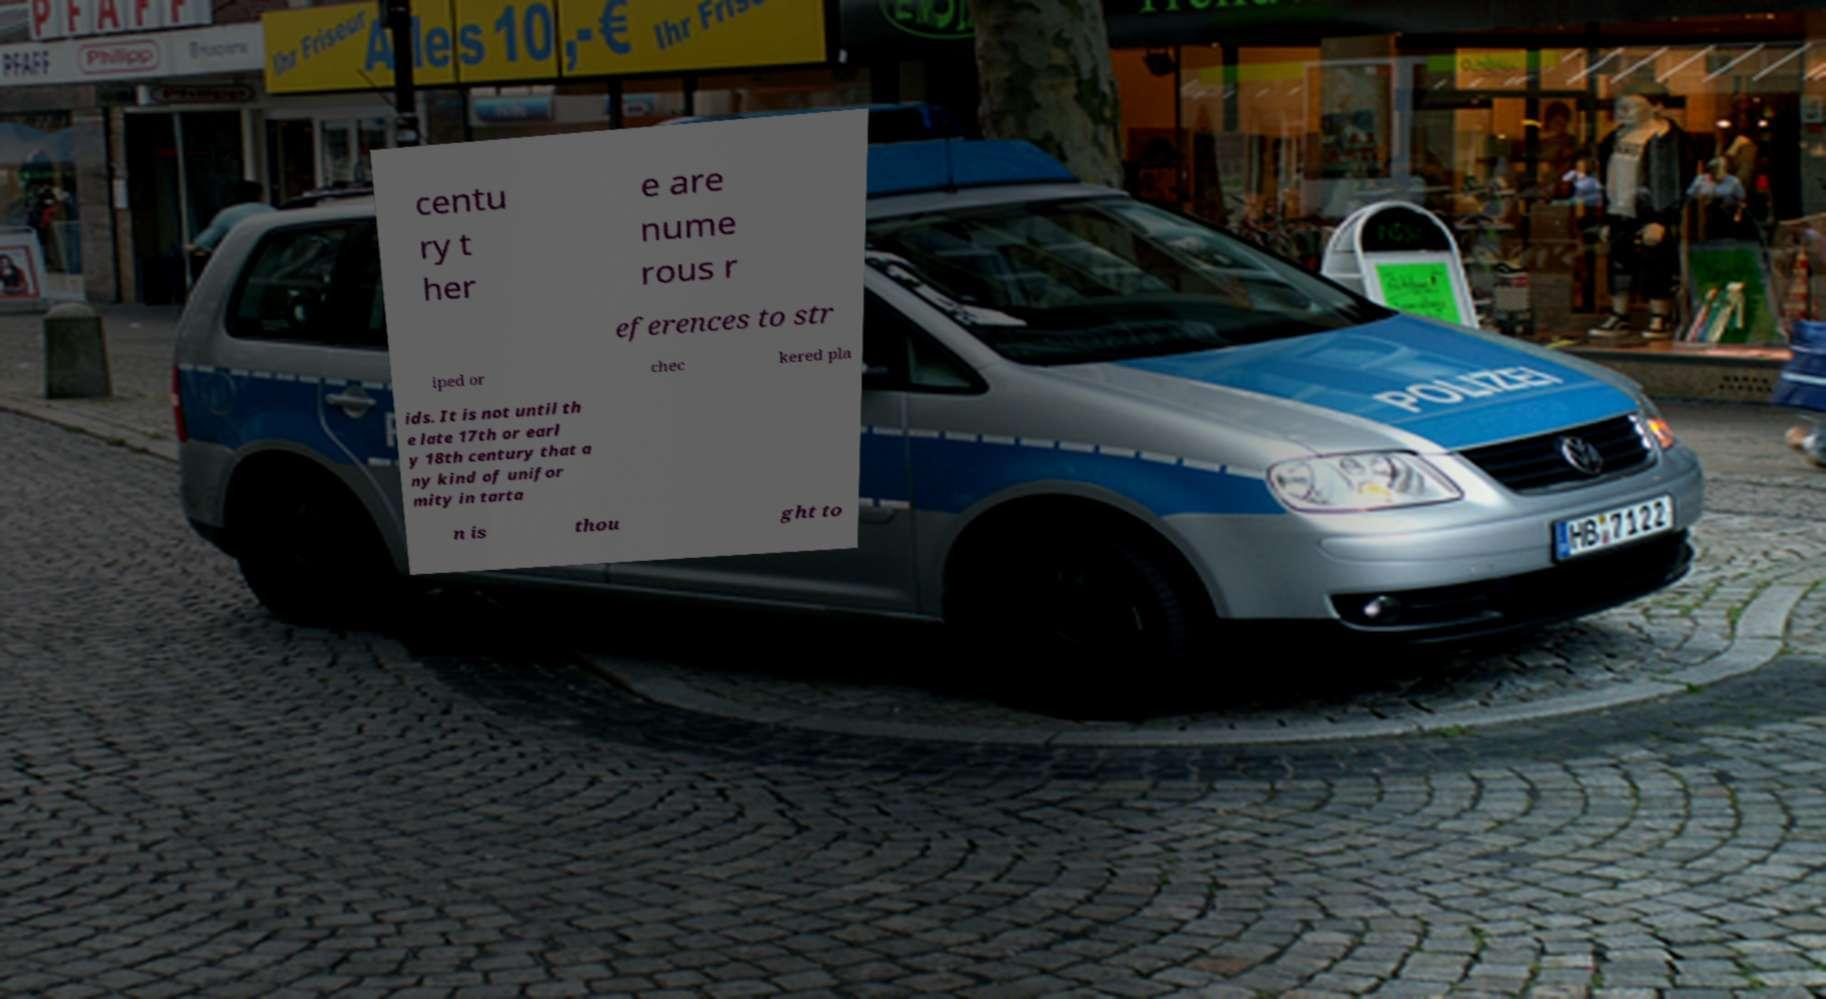Could you assist in decoding the text presented in this image and type it out clearly? centu ry t her e are nume rous r eferences to str iped or chec kered pla ids. It is not until th e late 17th or earl y 18th century that a ny kind of unifor mity in tarta n is thou ght to 